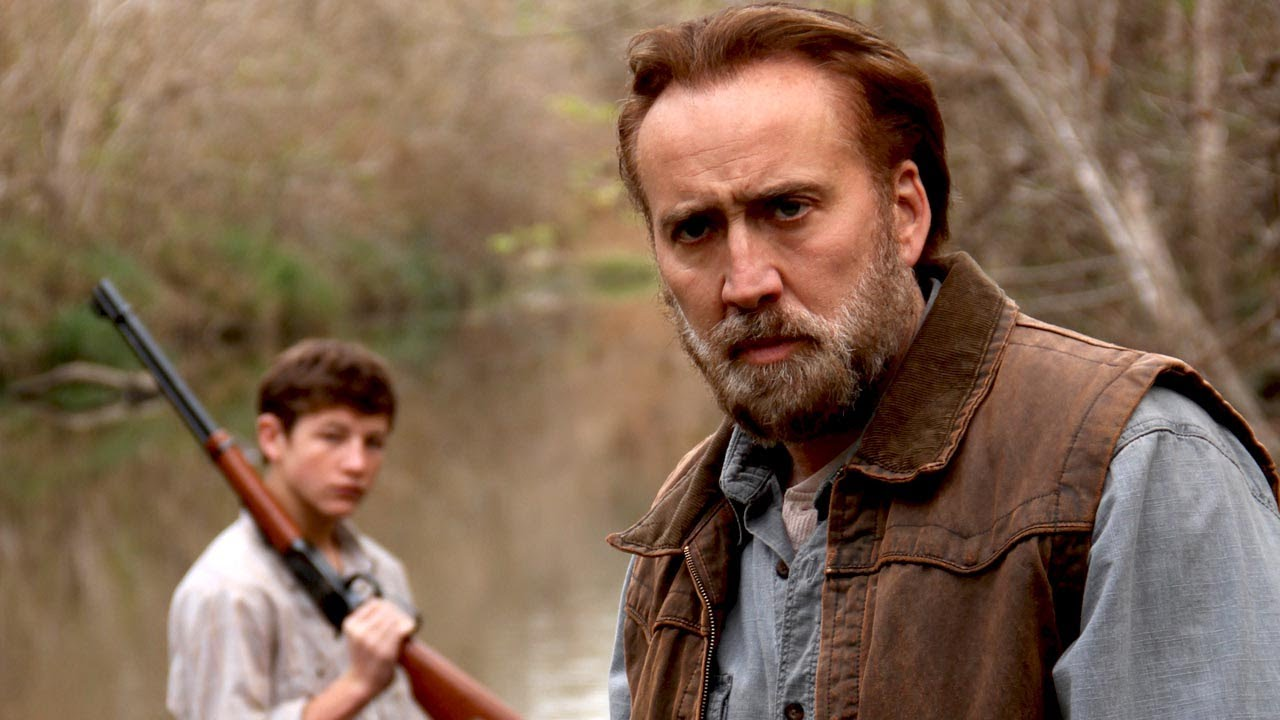Can you tell more about the relationship between the two characters here? The dynamic shown suggests a mentor-mentee or father-son relationship, characterized by a serious, possibly instructive moment. Their similar attire and serious expressions imply a shared endeavor or responsibility, often seen in familial or close-knit teacher-student relationships in rural settings. 